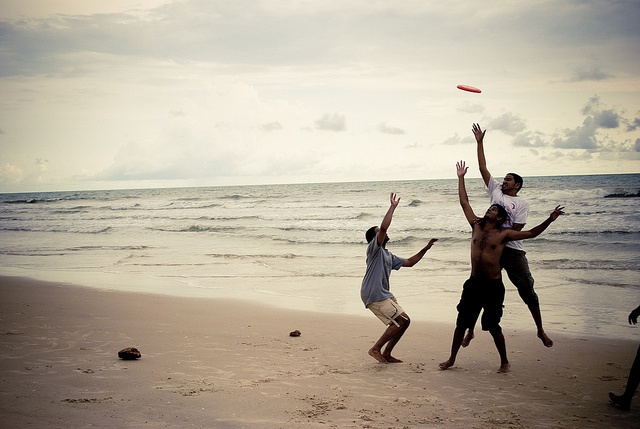Describe the objects in this image and their specific colors. I can see people in darkgray, black, maroon, and tan tones, people in darkgray, black, gray, and maroon tones, people in darkgray, black, maroon, and gray tones, people in darkgray, black, and gray tones, and frisbee in darkgray, lightpink, brown, maroon, and beige tones in this image. 